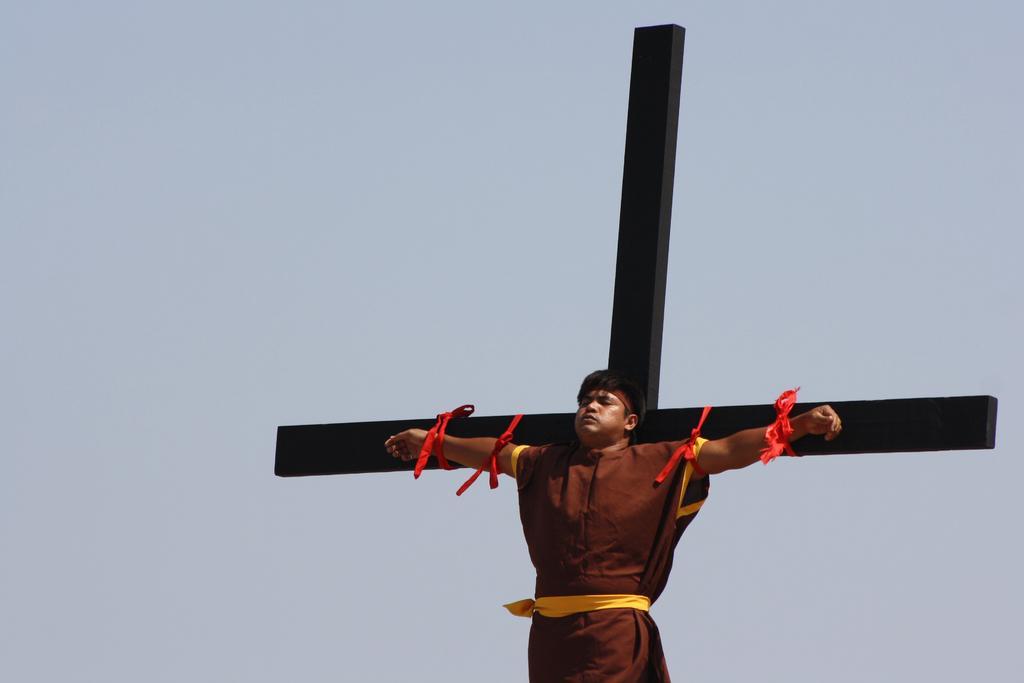Please provide a concise description of this image. There is a person hanging on the cross. Behind the cross there is sky. 